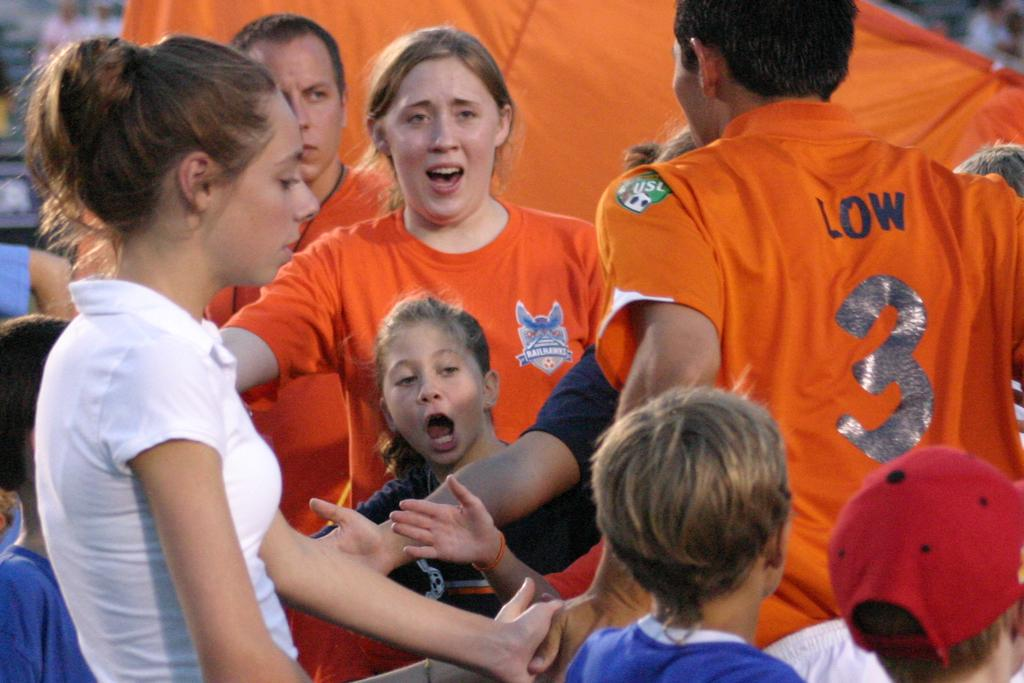<image>
Give a short and clear explanation of the subsequent image. A group of people gathered around a person with the number three on it. 